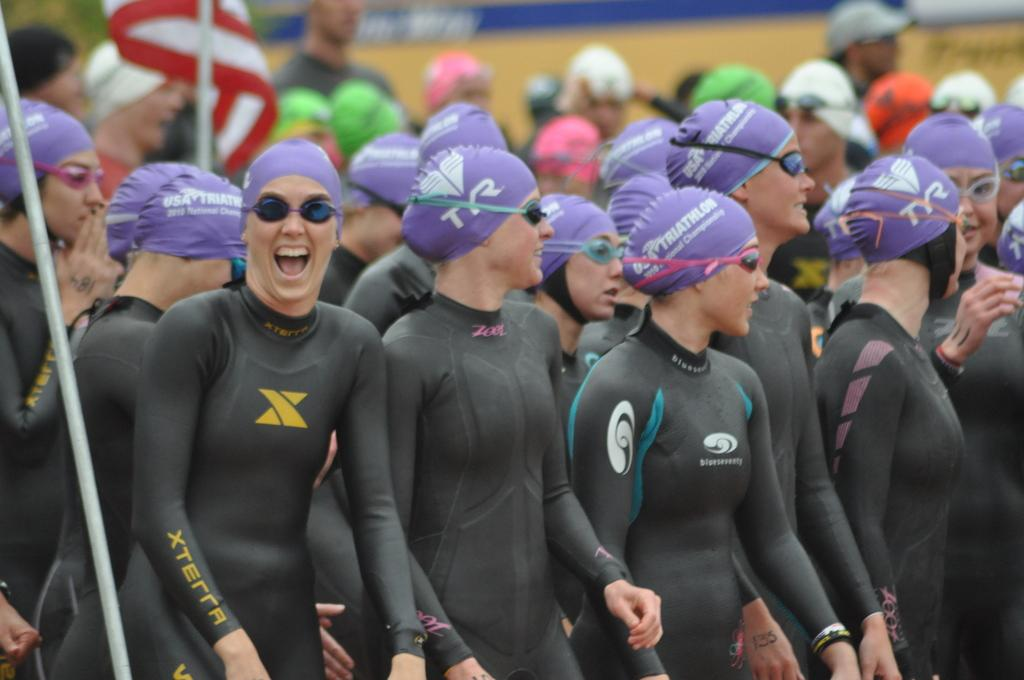How many people are in the image? There are people in the image, but the exact number is not specified. What are the people doing in the image? The people are standing in the image. What accessories are the people wearing in the image? The people are wearing spectacles and caps in the image. What color are the people's clothes in the image? The people are wearing black color dress in the image. What additional element can be seen in the image? There is a flag in the image. What type of rice is being cooked in the image? There is no rice present in the image; it features people standing and wearing spectacles, caps, and black color dress, along with a flag. 